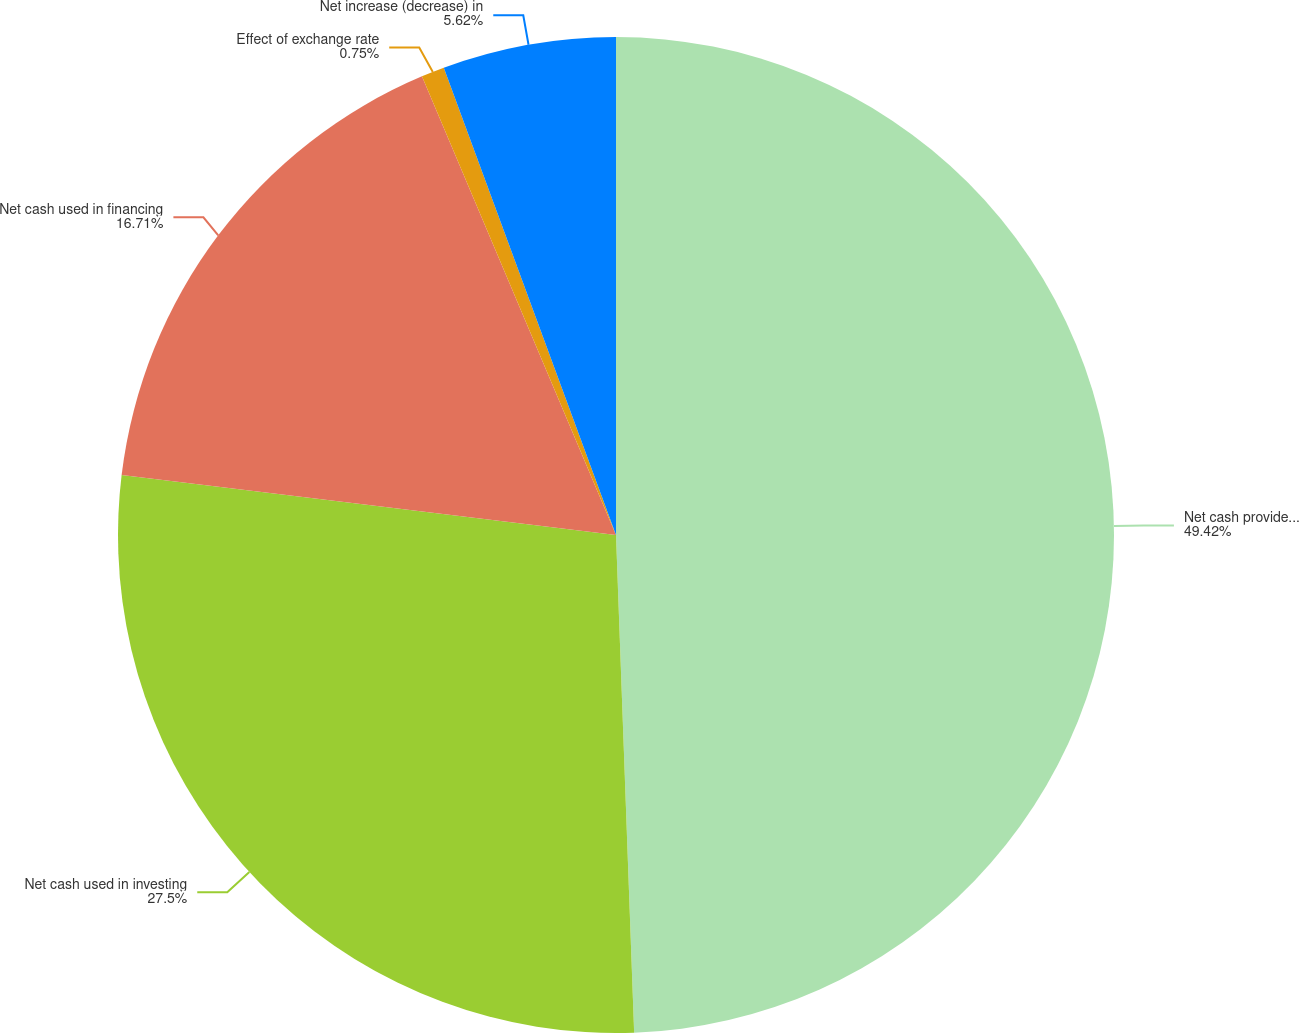Convert chart to OTSL. <chart><loc_0><loc_0><loc_500><loc_500><pie_chart><fcel>Net cash provided by operating<fcel>Net cash used in investing<fcel>Net cash used in financing<fcel>Effect of exchange rate<fcel>Net increase (decrease) in<nl><fcel>49.42%<fcel>27.5%<fcel>16.71%<fcel>0.75%<fcel>5.62%<nl></chart> 